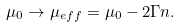Convert formula to latex. <formula><loc_0><loc_0><loc_500><loc_500>\mu _ { 0 } \rightarrow \mu _ { e f f } = \mu _ { 0 } - 2 \Gamma n .</formula> 